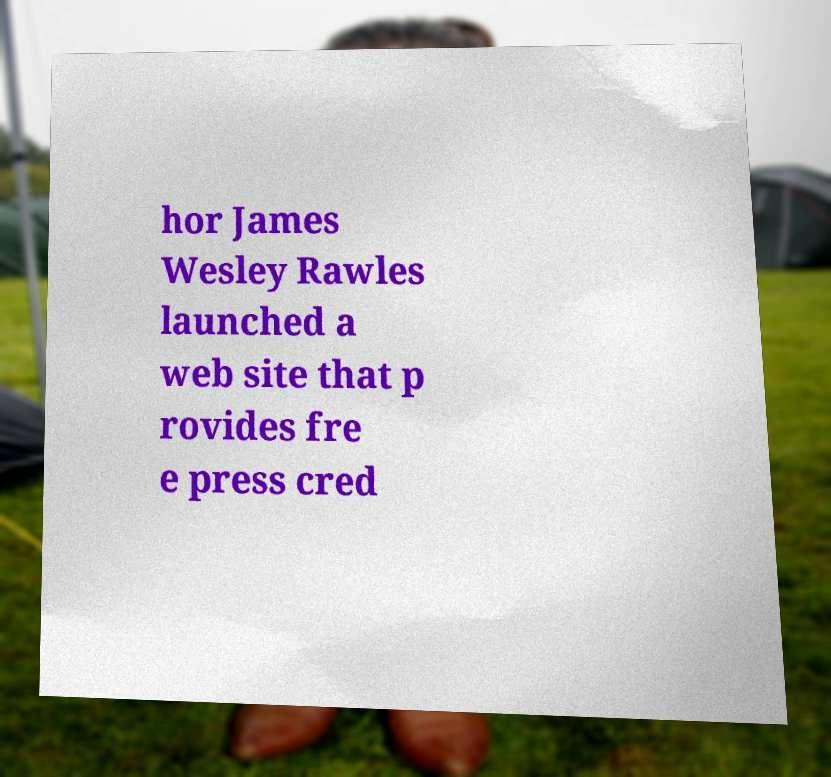Can you accurately transcribe the text from the provided image for me? hor James Wesley Rawles launched a web site that p rovides fre e press cred 